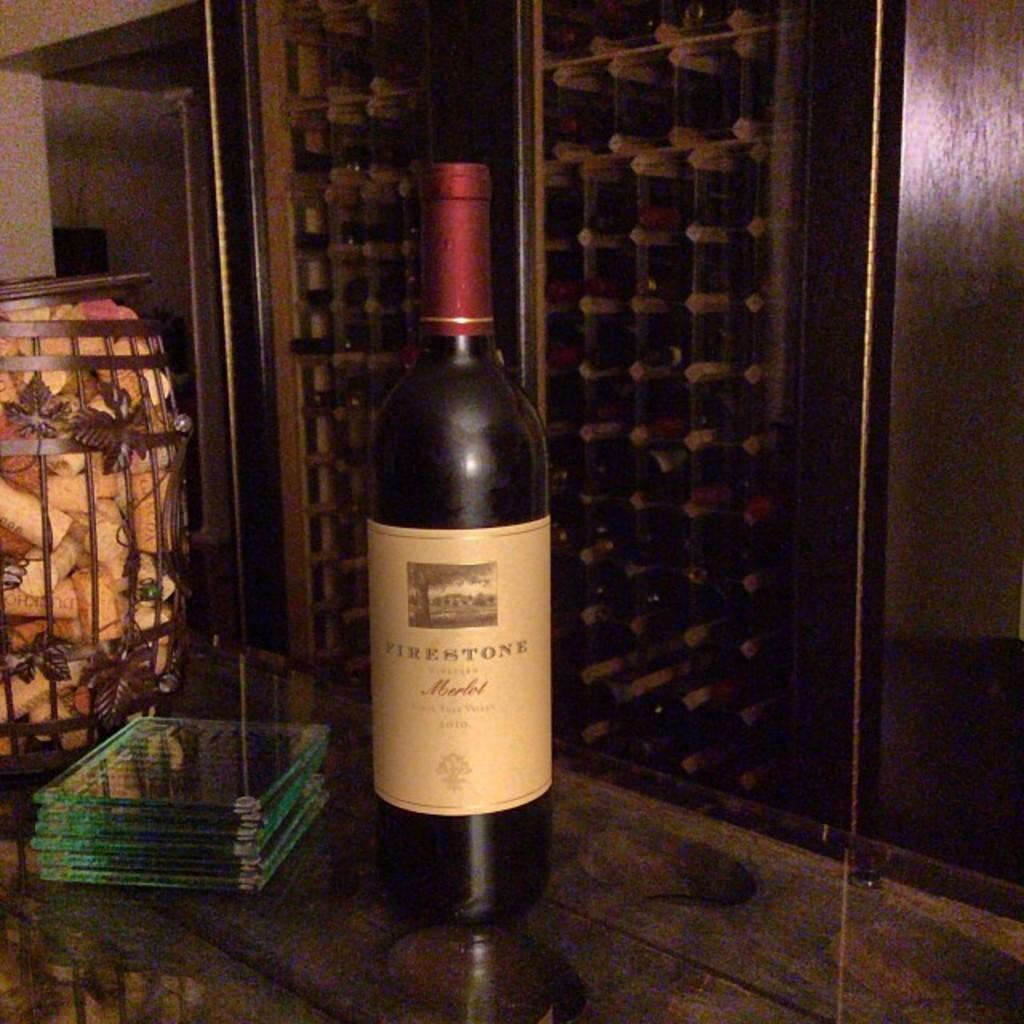<image>
Render a clear and concise summary of the photo. Alcohol bottle with the word FIRESTONE on it. 